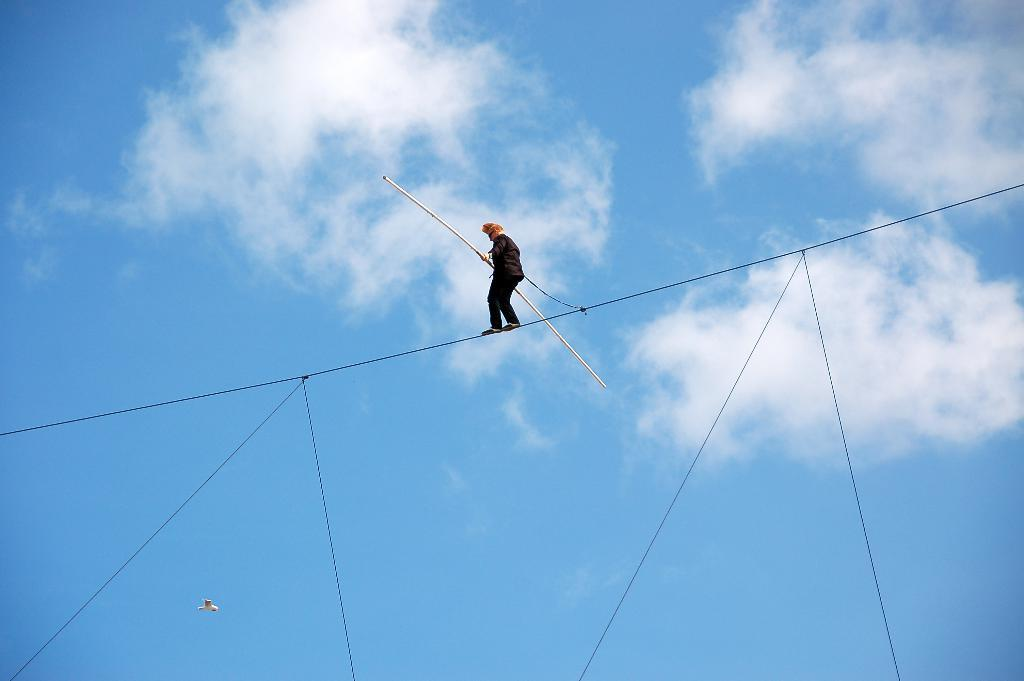What is the main subject of the image? There is a person in the image. What is the person wearing? The person is wearing clothes. What is the person holding in the image? The person is holding a long stick. What is the person doing in the image? The person is walking on a rope. What else can be seen in the image besides the person? There is a bird flying in the image, and the sky is cloudy and pale blue. What type of power is being generated by the person in the image? There is no indication in the image that the person is generating any power. What songs is the bird singing in the image? Birds do not sing songs, and there is no indication in the image that the bird is making any sounds. 